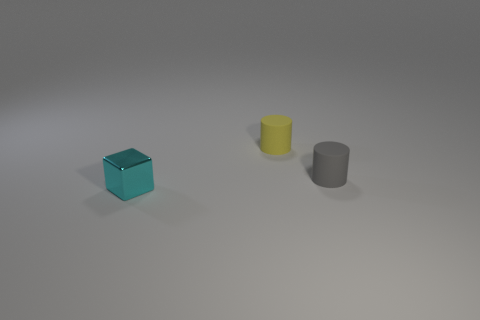Are there any other things that are the same material as the small cyan object?
Provide a short and direct response. No. There is a small cylinder in front of the tiny rubber cylinder to the left of the small gray rubber cylinder; how many cylinders are to the left of it?
Provide a short and direct response. 1. Do the object behind the gray matte object and the thing in front of the gray rubber thing have the same size?
Your answer should be compact. Yes. What is the thing in front of the matte cylinder that is in front of the yellow rubber object made of?
Keep it short and to the point. Metal. What number of objects are things behind the tiny cyan object or cyan metal objects?
Your answer should be compact. 3. Is the number of tiny rubber cylinders that are right of the gray object the same as the number of shiny things to the left of the tiny yellow matte cylinder?
Offer a terse response. No. There is a cylinder that is on the left side of the matte cylinder that is right of the small object behind the small gray matte thing; what is its material?
Provide a succinct answer. Rubber. There is a thing that is behind the cube and to the left of the small gray matte object; how big is it?
Keep it short and to the point. Small. Does the tiny gray object have the same shape as the cyan shiny object?
Provide a succinct answer. No. There is a object that is the same material as the yellow cylinder; what shape is it?
Provide a short and direct response. Cylinder. 